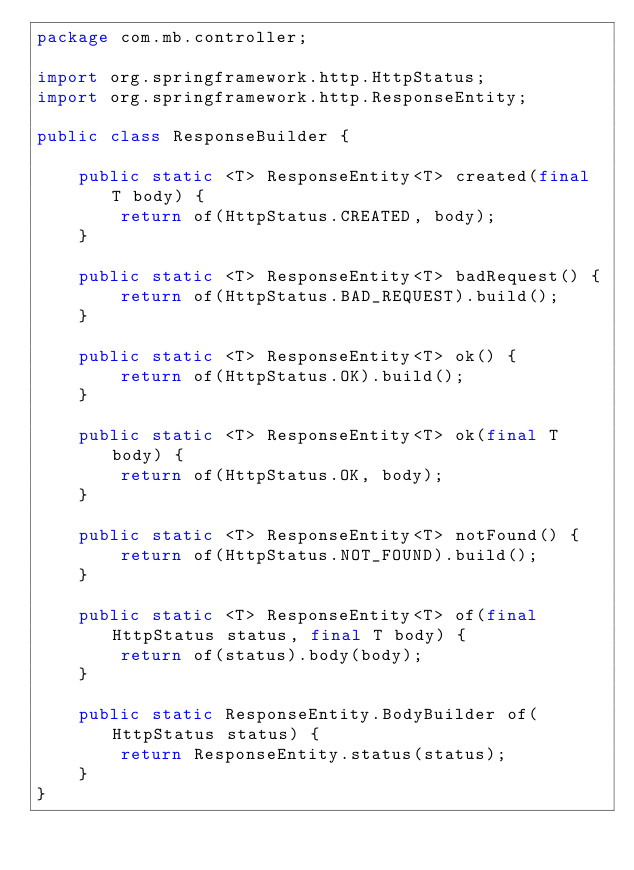Convert code to text. <code><loc_0><loc_0><loc_500><loc_500><_Java_>package com.mb.controller;

import org.springframework.http.HttpStatus;
import org.springframework.http.ResponseEntity;

public class ResponseBuilder {

    public static <T> ResponseEntity<T> created(final T body) {
        return of(HttpStatus.CREATED, body);
    }

    public static <T> ResponseEntity<T> badRequest() {
        return of(HttpStatus.BAD_REQUEST).build();
    }

    public static <T> ResponseEntity<T> ok() {
        return of(HttpStatus.OK).build();
    }

    public static <T> ResponseEntity<T> ok(final T body) {
        return of(HttpStatus.OK, body);
    }

    public static <T> ResponseEntity<T> notFound() {
        return of(HttpStatus.NOT_FOUND).build();
    }

    public static <T> ResponseEntity<T> of(final HttpStatus status, final T body) {
        return of(status).body(body);
    }

    public static ResponseEntity.BodyBuilder of(HttpStatus status) {
        return ResponseEntity.status(status);
    }
}
</code> 